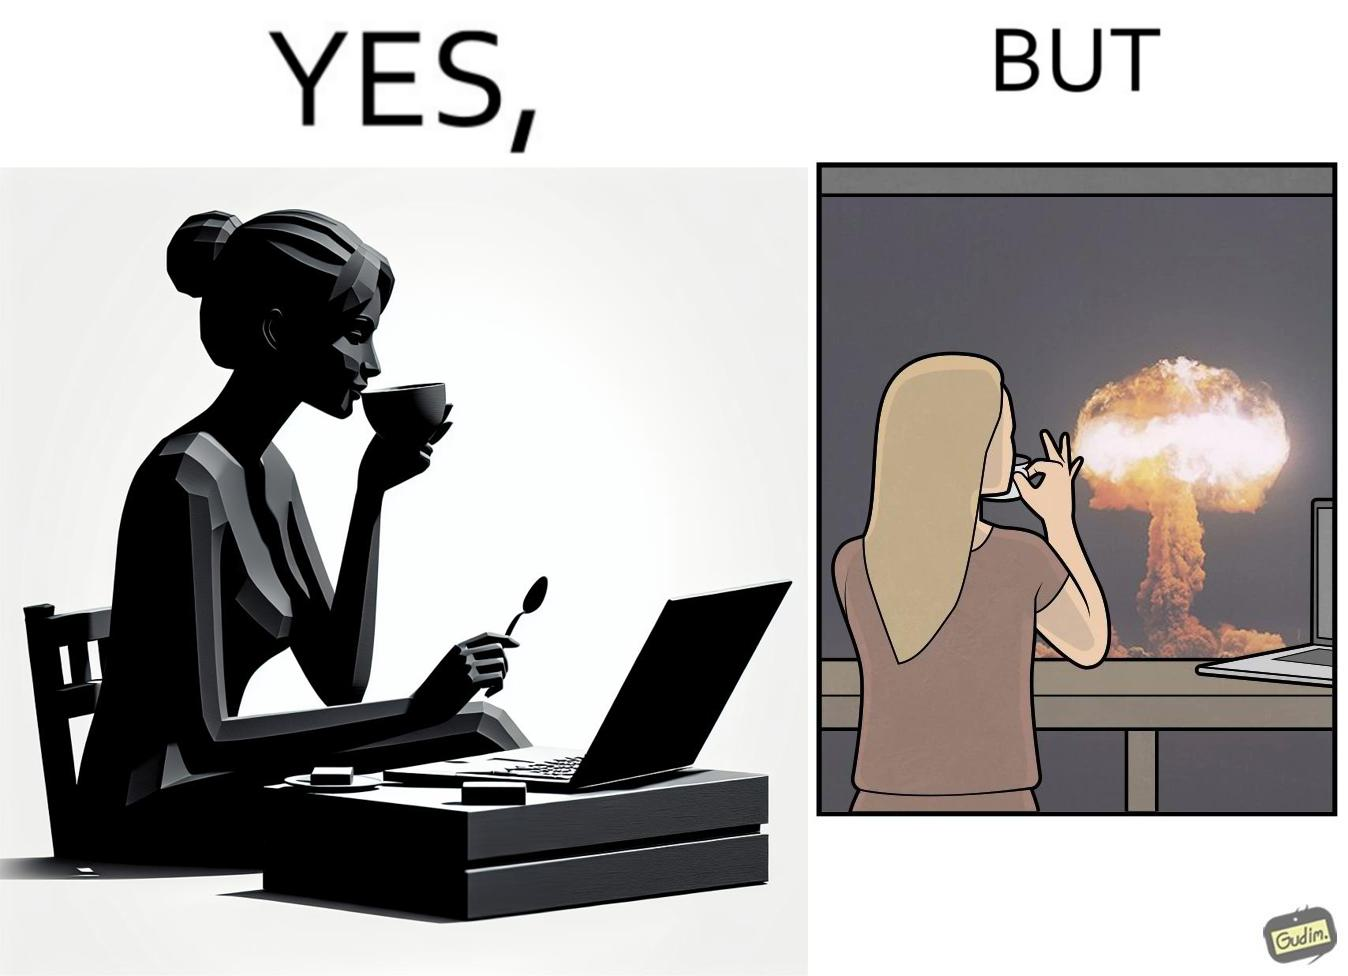Provide a description of this image. The images are funny since it shows a woman simply sipping from a cup at ease in a cafe with her laptop not caring about anything going on outside the cafe even though the situation is very grave,that is, a nuclear blast 